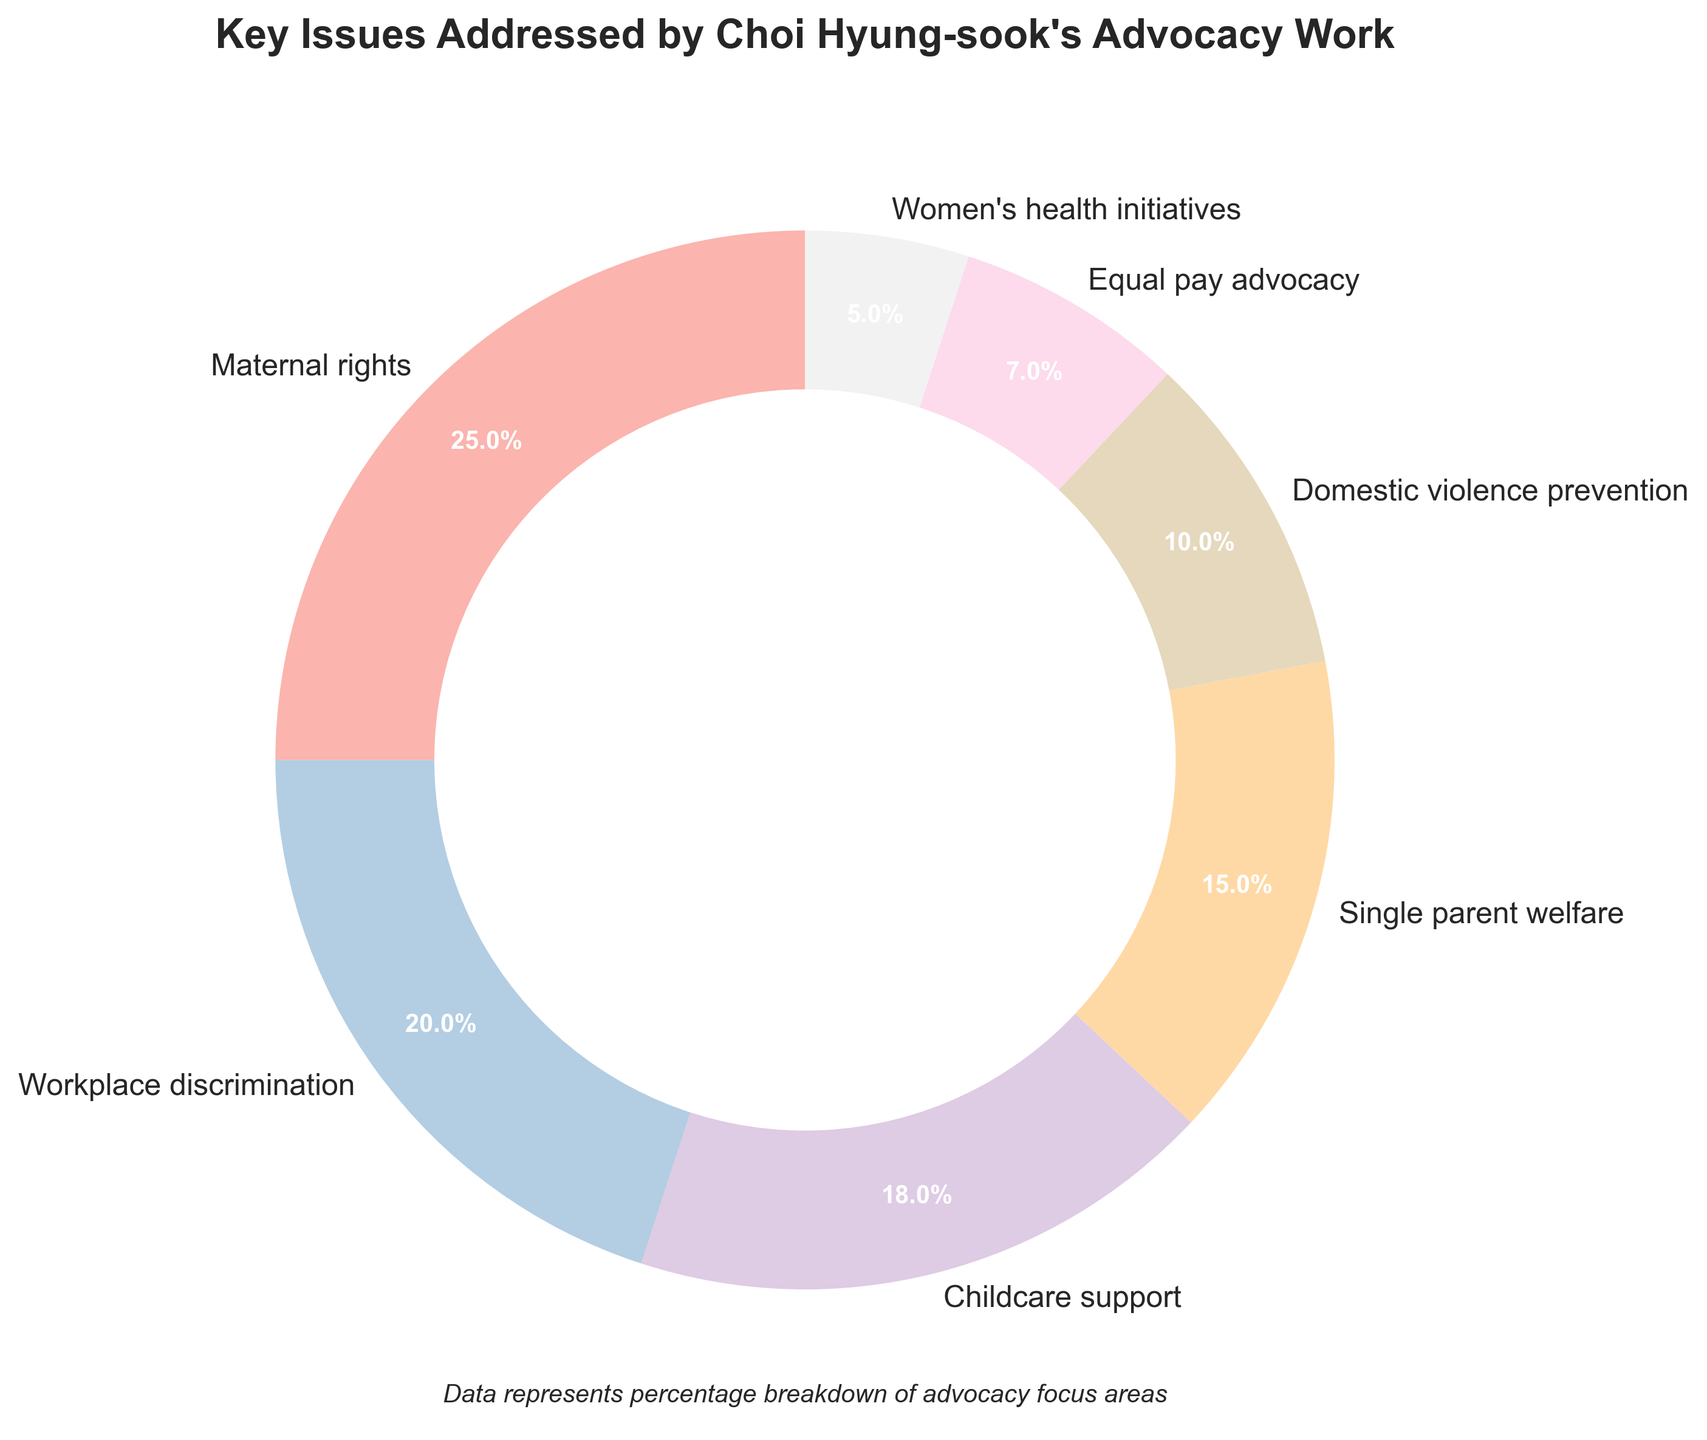What percentage of Choi Hyung-sook's advocacy work is dedicated to maternal rights? Look at the "Maternal rights" segment of the pie chart and read the percentage labeled on it.
Answer: 25% How do the percentages for childcare support and domestic violence prevention compare? Find the labels for "Childcare support" and "Domestic violence prevention" and compare their percentages.
Answer: Childcare support is 18% and domestic violence prevention is 10% Which issue receives the least focus in Choi Hyung-sook's advocacy work? Identify the segment with the smallest percentage from the pie chart.
Answer: Women's health initiatives What is the combined percentage of maternal rights and workplace discrimination? Locate the percentages for "Maternal rights" (25%) and "Workplace discrimination" (20%). Add them together: 25% + 20% = 45%.
Answer: 45% Is the percentage dedicated to equal pay advocacy greater than or less than the percentage dedicated to domestic violence prevention? Find the percentages for "Equal pay advocacy" and "Domestic violence prevention" and then compare them. 7% < 10%.
Answer: Less than What is the difference in focus between single parent welfare and childcare support? Locate the percentages for "Single parent welfare" (15%) and "Childcare support" (18%). Subtract the smaller from the larger: 18% - 15% = 3%.
Answer: 3% What is the average percentage dedicated to maternal rights, workplace discrimination, and childcare support? Add the percentages for the three issues (25%, 20%, and 18%) and divide by 3: (25% + 20% + 18%) / 3 = 21%.
Answer: 21% Which issue has the second highest focus in Choi Hyung-sook's advocacy work? Identify the issue with the second highest percentage after the highest one (Maternal rights at 25%). The second highest is "Workplace discrimination" at 20%.
Answer: Workplace discrimination How much more focus is given to single parent welfare than to women's health initiatives? Locate the percentages for "Single parent welfare" (15%) and "Women's health initiatives" (5%). Subtract the smaller from the larger: 15% - 5% = 10%.
Answer: 10% What percentage of Choi Hyung-sook's advocacy work is dedicated to non-child-related issues (excluding maternal rights, childcare support, and single parent welfare)? Add the percentages for all issues except maternal rights (25%), childcare support (18%), and single parent welfare (15%): 20% (Workplace discrimination) + 10% (Domestic violence prevention) + 7% (Equal pay advocacy) + 5% (Women's health initiatives). Total = 42%.
Answer: 42% 